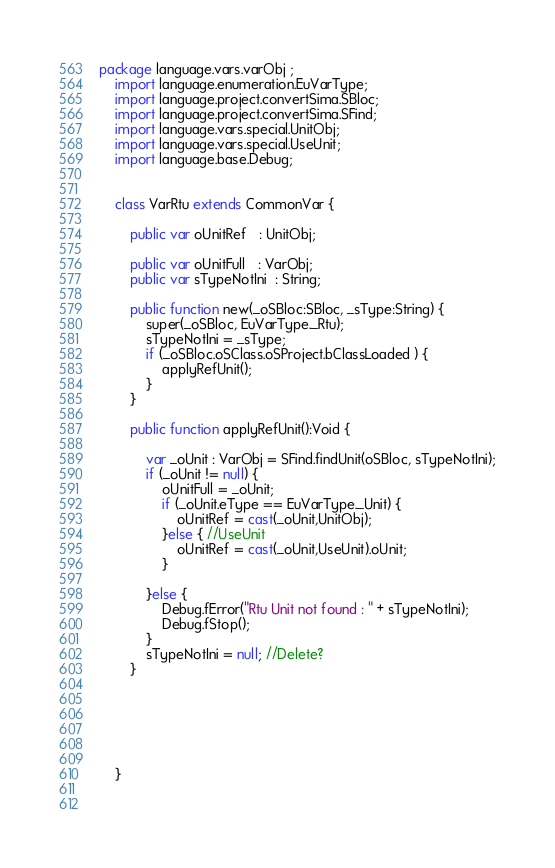Convert code to text. <code><loc_0><loc_0><loc_500><loc_500><_Haxe_>package language.vars.varObj ;
	import language.enumeration.EuVarType;
	import language.project.convertSima.SBloc;
	import language.project.convertSima.SFind;
	import language.vars.special.UnitObj;
	import language.vars.special.UseUnit;
	import language.base.Debug;
	

	class VarRtu extends CommonVar {

		public var oUnitRef   : UnitObj;
		
		public var oUnitFull   : VarObj;
		public var sTypeNotIni  : String;
		
		public function new(_oSBloc:SBloc, _sType:String) {
			super(_oSBloc, EuVarType._Rtu);
			sTypeNotIni = _sType;
			if (_oSBloc.oSClass.oSProject.bClassLoaded ) {
				applyRefUnit();
			}
		}
		
		public function applyRefUnit():Void {
			
			var _oUnit : VarObj = SFind.findUnit(oSBloc, sTypeNotIni);
			if (_oUnit != null) {
				oUnitFull = _oUnit;
				if (_oUnit.eType == EuVarType._Unit) {
					oUnitRef = cast(_oUnit,UnitObj);
				}else { //UseUnit
					oUnitRef = cast(_oUnit,UseUnit).oUnit;
				}
		
			}else {
				Debug.fError("Rtu Unit not found : " + sTypeNotIni);
				Debug.fStop();
			}
			sTypeNotIni = null; //Delete?
		}
		
		
		
		
		
		
	}
	
		
</code> 